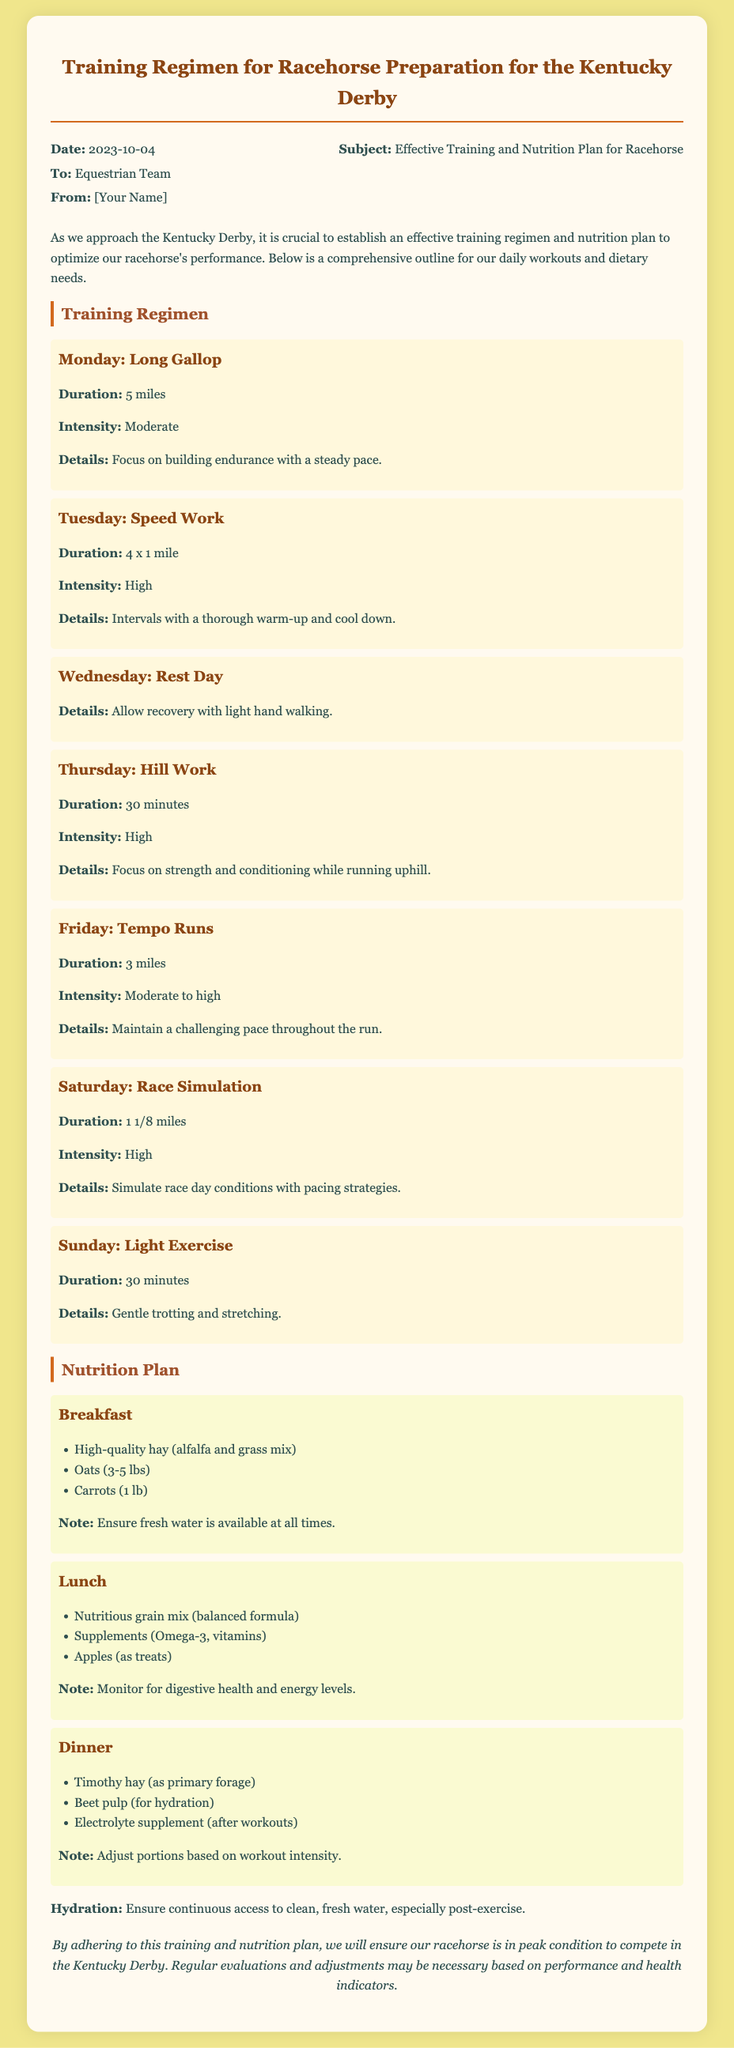What is the date of the memo? The date of the memo is mentioned at the top, which is when it was created.
Answer: 2023-10-04 Who is the memo addressed to? The recipient of the memo is stated in the header.
Answer: Equestrian Team What is the primary focus of the training regimen? The focus of the training regimen is detailed at the top of the section.
Answer: Performance optimization How long is the long gallop on Monday? The duration of Monday's workout is specifically listed.
Answer: 5 miles What type of exercise is scheduled for Wednesday? The activity for Wednesday is clearly defined in the training schedule.
Answer: Rest Day What is included in the breakfast meal plan? The items in the breakfast reflect the horse's dietary needs.
Answer: Hay, oats, carrots What is the primary forage for dinner? The type of forage for dinner is explicitly stated in the nutrition plan.
Answer: Timothy hay What should be monitored during lunch? The memo specifies an aspect of health to keep an eye on during lunchtime.
Answer: Digestive health What is the emphasis of the hill work exercise on Thursday? The main focus of the Thursday workout is clearly described.
Answer: Strength and conditioning 